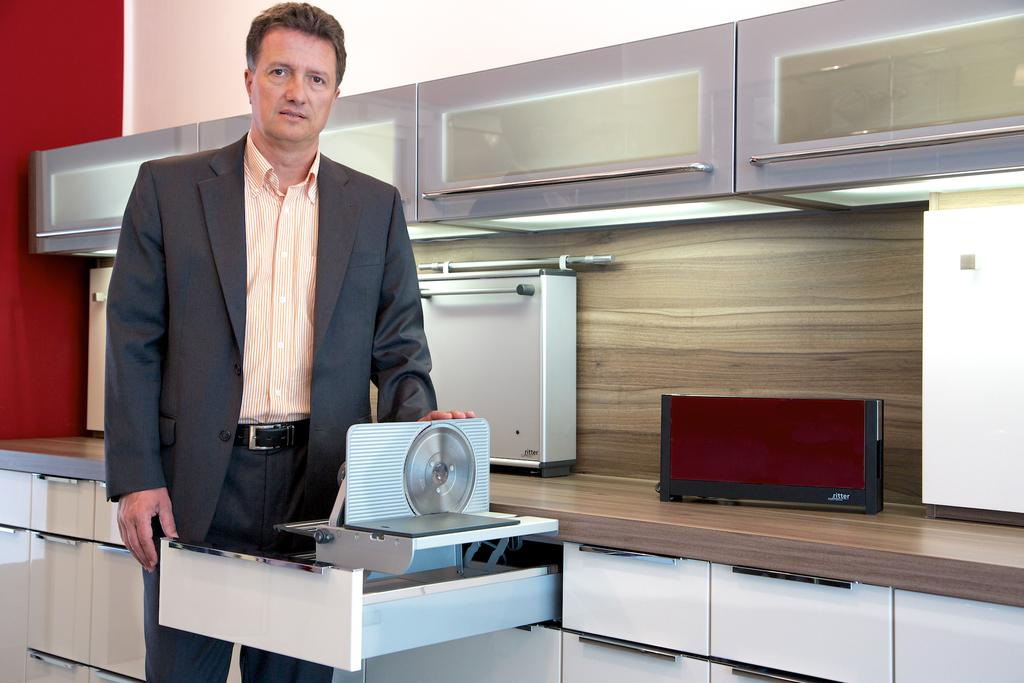What is the person in the image wearing? The person in the image is wearing a suit. Where is the person standing in relation to the cabinet? The person is standing beside the cabinet. How many racks does the cabinet have? The cabinet has multiple racks. What is on top of the cabinet? There is an object on the cabinet. What type of furniture is attached to the wall in the image? There are cupboards attached to the wall in the image. What type of behavior does the duck exhibit in the image? There is no duck present in the image, so it is not possible to answer that question. 